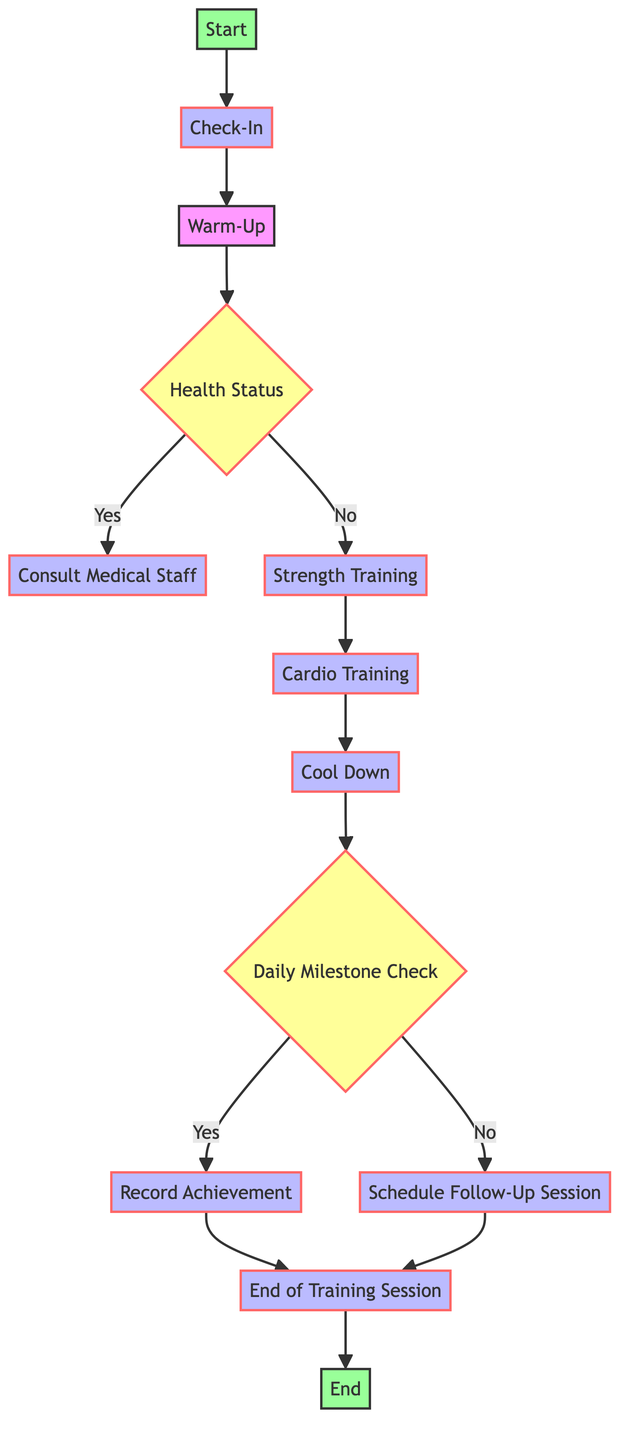What's the first step in the training regimen? The first step is "Check-In," which involves the morning roll call and health assessment. This is the starting point of the diagram, leading to the next node.
Answer: Check-In How many types of training are included after the Warm-Up? After the Warm-Up, there are two types of training: "Strength Training" and "Cardio Training." Both processes follow the Warm-Up step in the flow of the diagram.
Answer: Two What should a soldier do if there is a health issue identified? If health issues are identified, the soldier should "Consult Medical Staff." This is the decision branch stemming from the Health Status check, indicating the next action in case of health concerns.
Answer: Consult Medical Staff What is the total duration of the physical training before the Cool Down? The total duration before the Cool Down consists of 45 minutes of Strength Training and 30 minutes of Cardio Training, totaling 75 minutes of physical training before the Cool Down begins.
Answer: 75 minutes What determines whether a soldier records an achievement for the day? The soldier's ability to meet the day's physical training goals, assessed during the "Daily Milestone Check," determines if they will record an achievement. If they successfully complete, they record it; otherwise, they schedule a follow-up session.
Answer: Daily Milestone Check If a soldier does not complete the physical training goals, what is the next step? If the physical training goals are not met, the next step is to "Schedule Follow-Up Session." This is the path chosen if they answer 'no' during the Daily Milestone Check.
Answer: Schedule Follow-Up Session How does the training regimen proceed after the Warm-Up? After the Warm-Up, the training regimen proceeds to the "Health Status" decision node, where the soldier’s health is assessed, determining the subsequent steps according to whether health issues are present.
Answer: Health Status What is the output after logging the training data? After logging training data and reviewing progress, the output is referred to as "End of Training Session." This signifies the completion of the entire process outlined in the diagram.
Answer: End of Training Session 